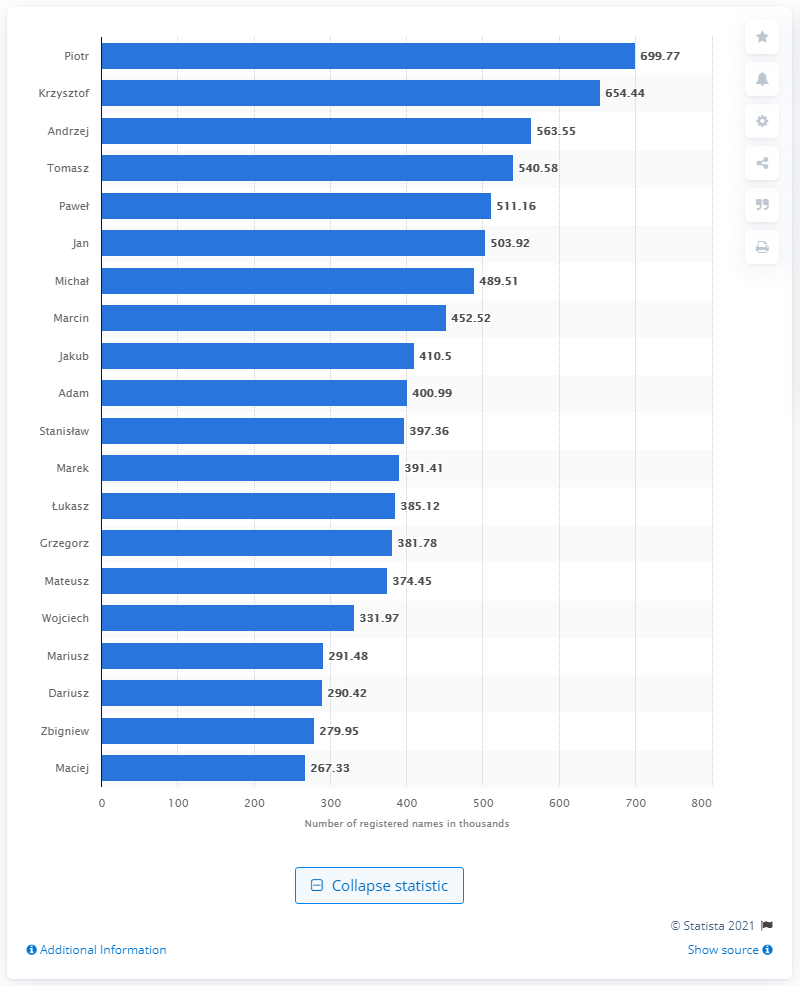Indicate a few pertinent items in this graphic. As of January 2021, the most popular male first name in Poland was Piotr. 